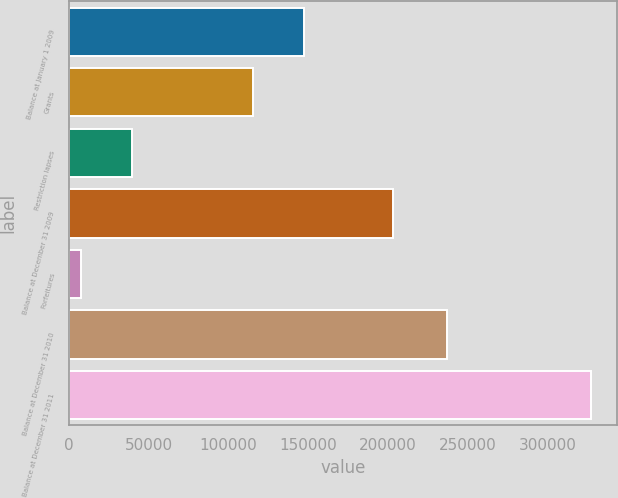Convert chart to OTSL. <chart><loc_0><loc_0><loc_500><loc_500><bar_chart><fcel>Balance at January 1 2009<fcel>Grants<fcel>Restriction lapses<fcel>Balance at December 31 2009<fcel>Forfeitures<fcel>Balance at December 31 2010<fcel>Balance at December 31 2011<nl><fcel>147010<fcel>115060<fcel>39450<fcel>203250<fcel>7500<fcel>237150<fcel>327000<nl></chart> 